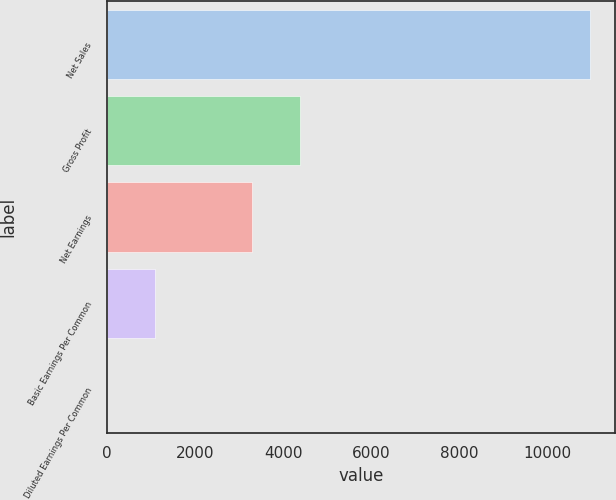Convert chart to OTSL. <chart><loc_0><loc_0><loc_500><loc_500><bar_chart><fcel>Net Sales<fcel>Gross Profit<fcel>Net Earnings<fcel>Basic Earnings Per Common<fcel>Diluted Earnings Per Common<nl><fcel>10976<fcel>4390.72<fcel>3293.18<fcel>1098.1<fcel>0.56<nl></chart> 